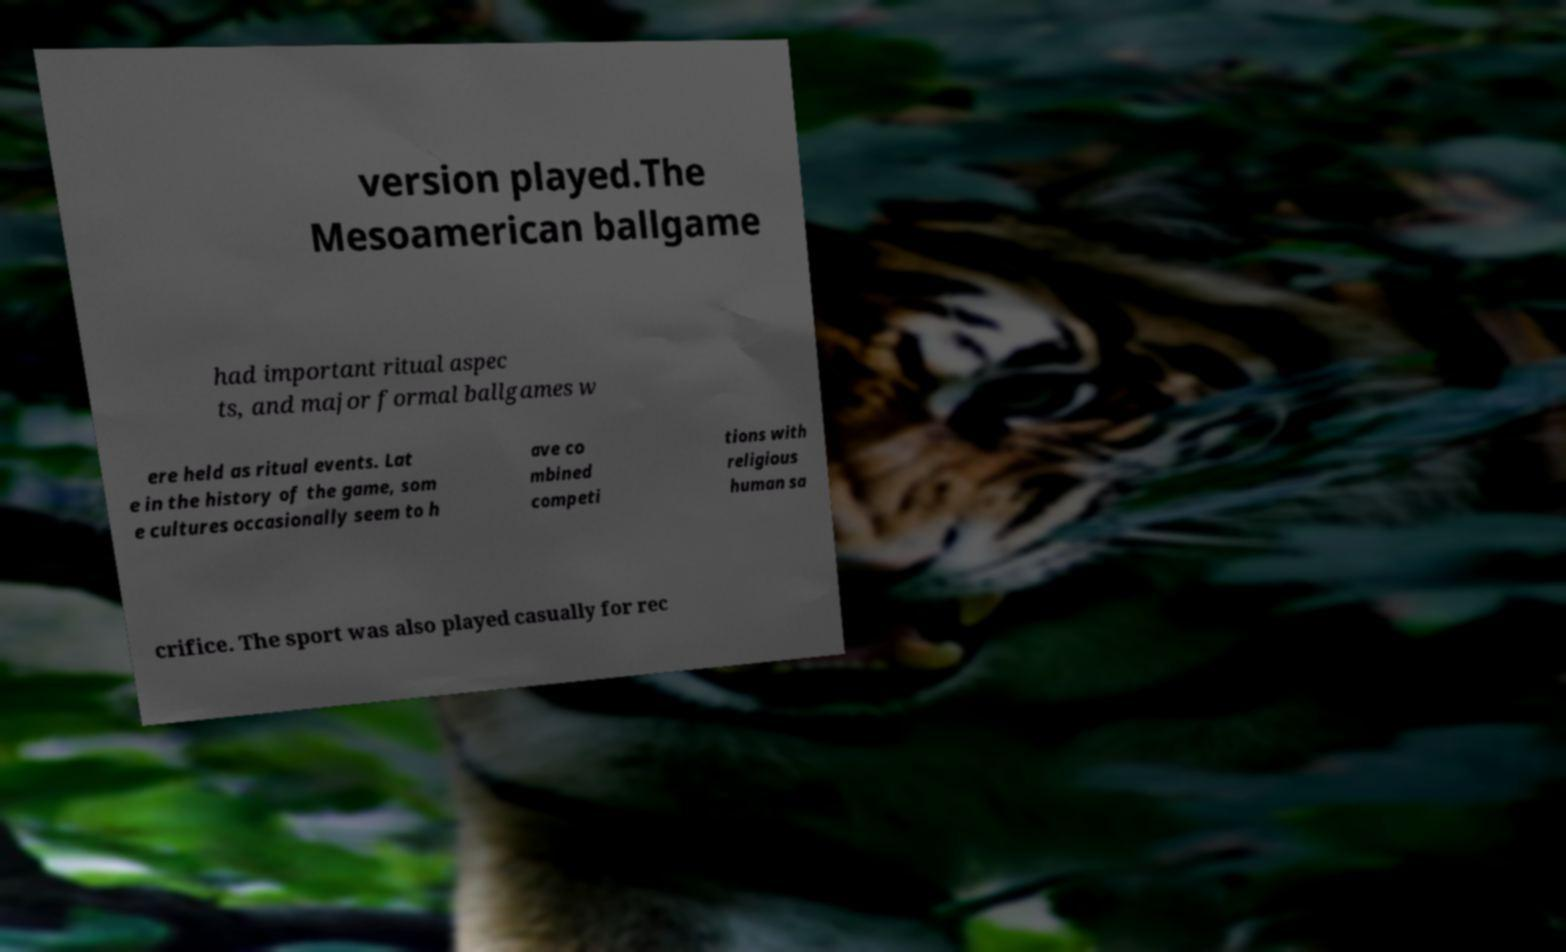I need the written content from this picture converted into text. Can you do that? version played.The Mesoamerican ballgame had important ritual aspec ts, and major formal ballgames w ere held as ritual events. Lat e in the history of the game, som e cultures occasionally seem to h ave co mbined competi tions with religious human sa crifice. The sport was also played casually for rec 